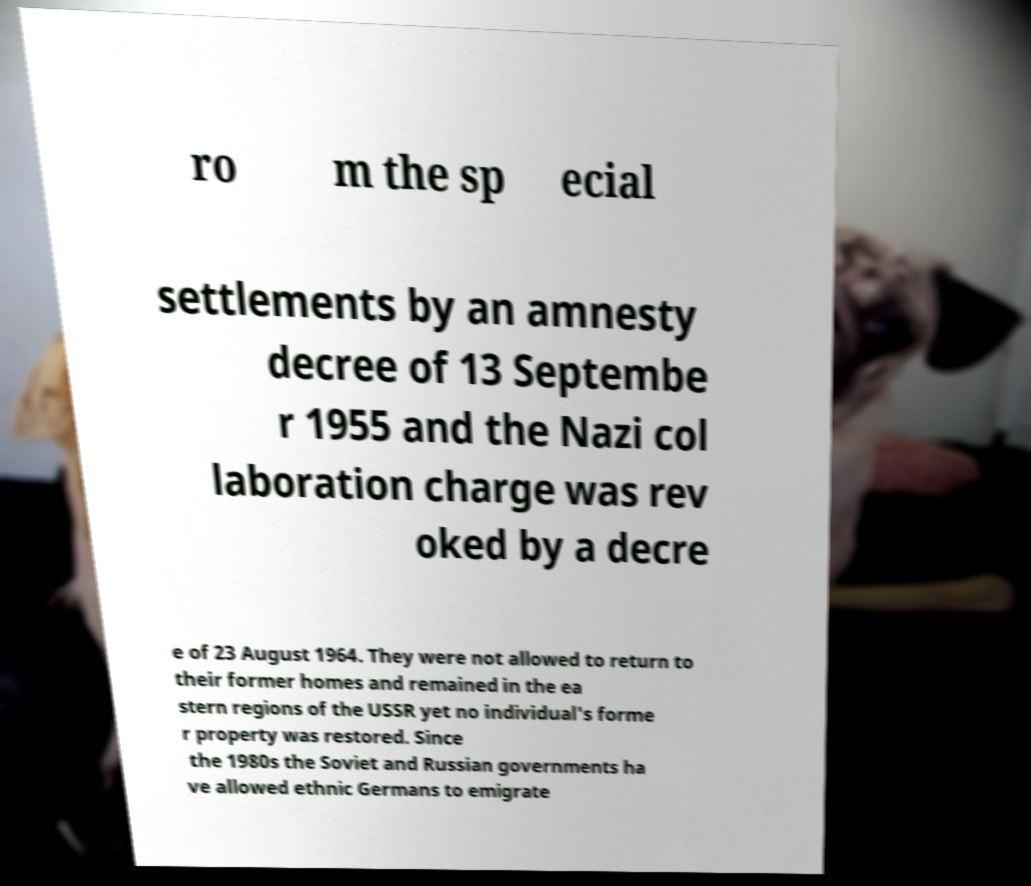Could you assist in decoding the text presented in this image and type it out clearly? ro m the sp ecial settlements by an amnesty decree of 13 Septembe r 1955 and the Nazi col laboration charge was rev oked by a decre e of 23 August 1964. They were not allowed to return to their former homes and remained in the ea stern regions of the USSR yet no individual's forme r property was restored. Since the 1980s the Soviet and Russian governments ha ve allowed ethnic Germans to emigrate 